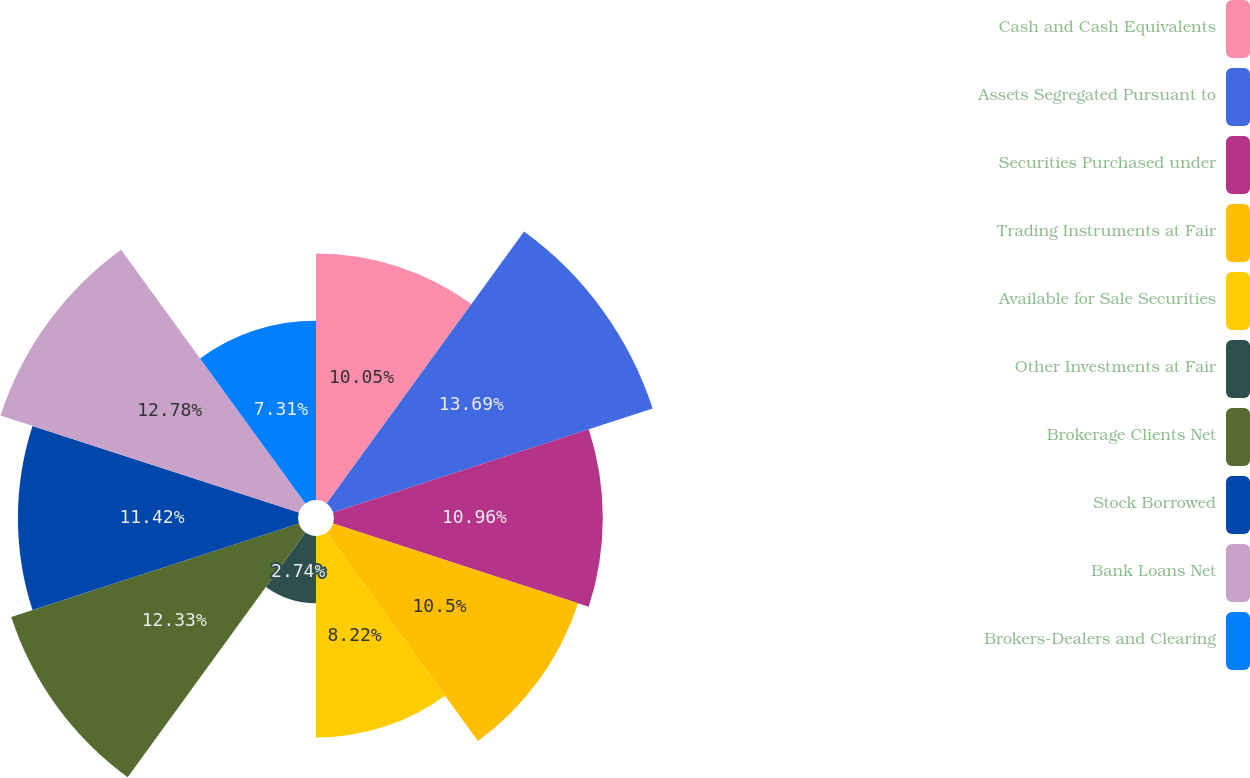<chart> <loc_0><loc_0><loc_500><loc_500><pie_chart><fcel>Cash and Cash Equivalents<fcel>Assets Segregated Pursuant to<fcel>Securities Purchased under<fcel>Trading Instruments at Fair<fcel>Available for Sale Securities<fcel>Other Investments at Fair<fcel>Brokerage Clients Net<fcel>Stock Borrowed<fcel>Bank Loans Net<fcel>Brokers-Dealers and Clearing<nl><fcel>10.05%<fcel>13.7%<fcel>10.96%<fcel>10.5%<fcel>8.22%<fcel>2.74%<fcel>12.33%<fcel>11.42%<fcel>12.79%<fcel>7.31%<nl></chart> 